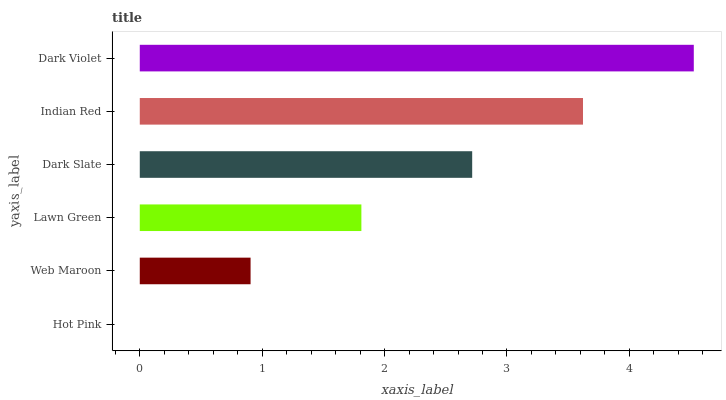Is Hot Pink the minimum?
Answer yes or no. Yes. Is Dark Violet the maximum?
Answer yes or no. Yes. Is Web Maroon the minimum?
Answer yes or no. No. Is Web Maroon the maximum?
Answer yes or no. No. Is Web Maroon greater than Hot Pink?
Answer yes or no. Yes. Is Hot Pink less than Web Maroon?
Answer yes or no. Yes. Is Hot Pink greater than Web Maroon?
Answer yes or no. No. Is Web Maroon less than Hot Pink?
Answer yes or no. No. Is Dark Slate the high median?
Answer yes or no. Yes. Is Lawn Green the low median?
Answer yes or no. Yes. Is Web Maroon the high median?
Answer yes or no. No. Is Hot Pink the low median?
Answer yes or no. No. 